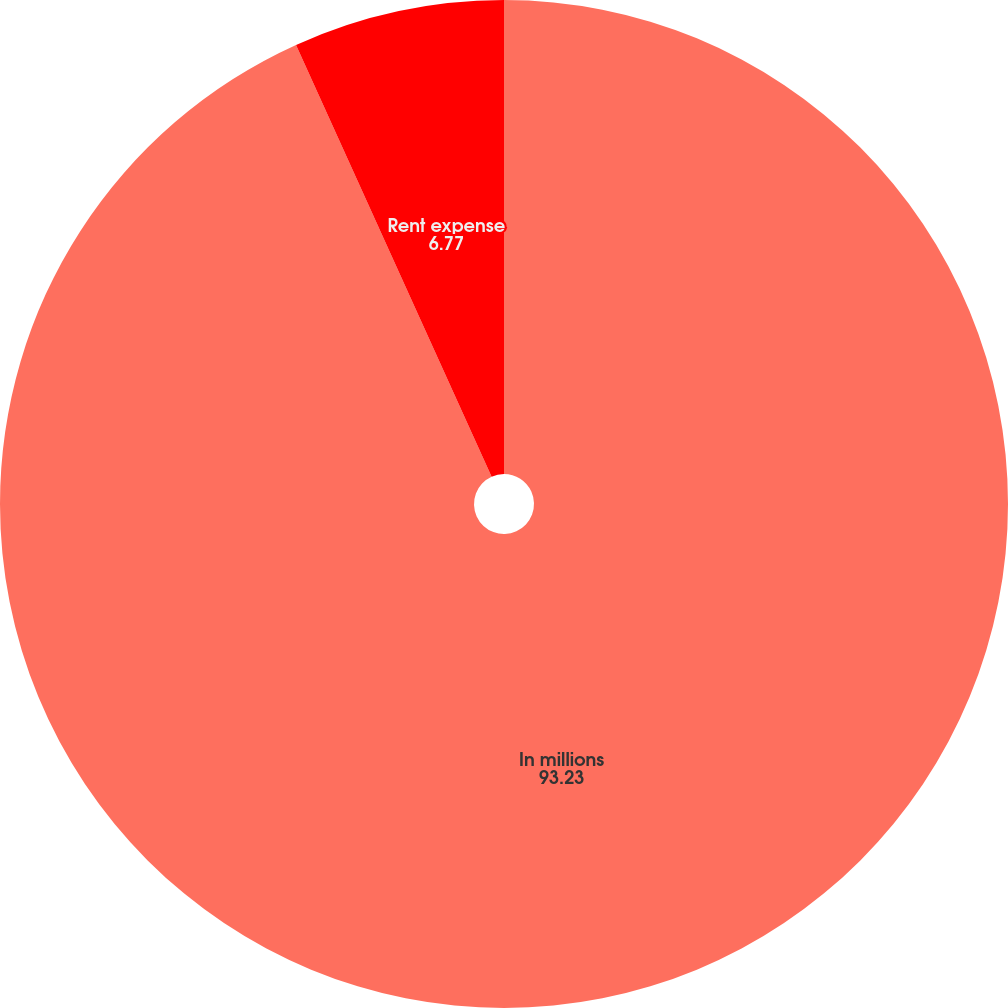<chart> <loc_0><loc_0><loc_500><loc_500><pie_chart><fcel>In millions<fcel>Rent expense<nl><fcel>93.23%<fcel>6.77%<nl></chart> 